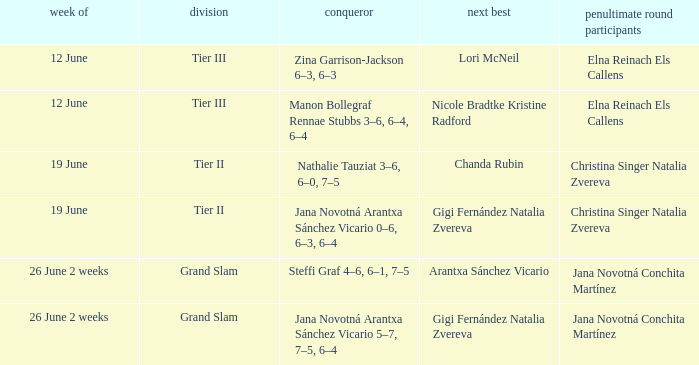When the Tier is listed as tier iii, who is the Winner? Zina Garrison-Jackson 6–3, 6–3, Manon Bollegraf Rennae Stubbs 3–6, 6–4, 6–4. 